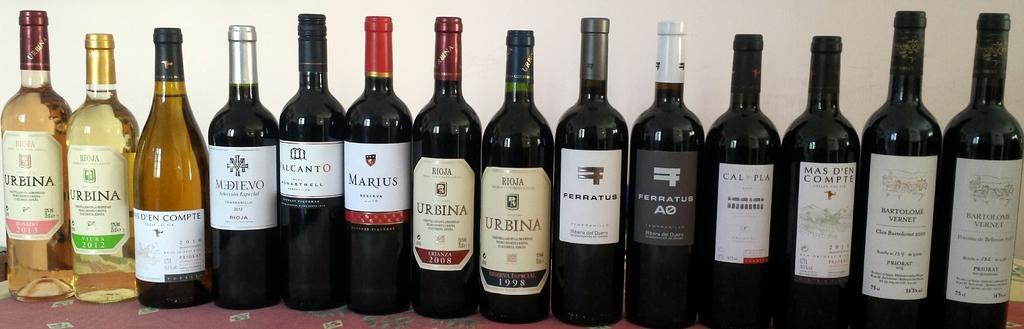Describe this image in one or two sentences. in this picture we can see a number of bottles with a label on it ,which is filled with the liquid. 